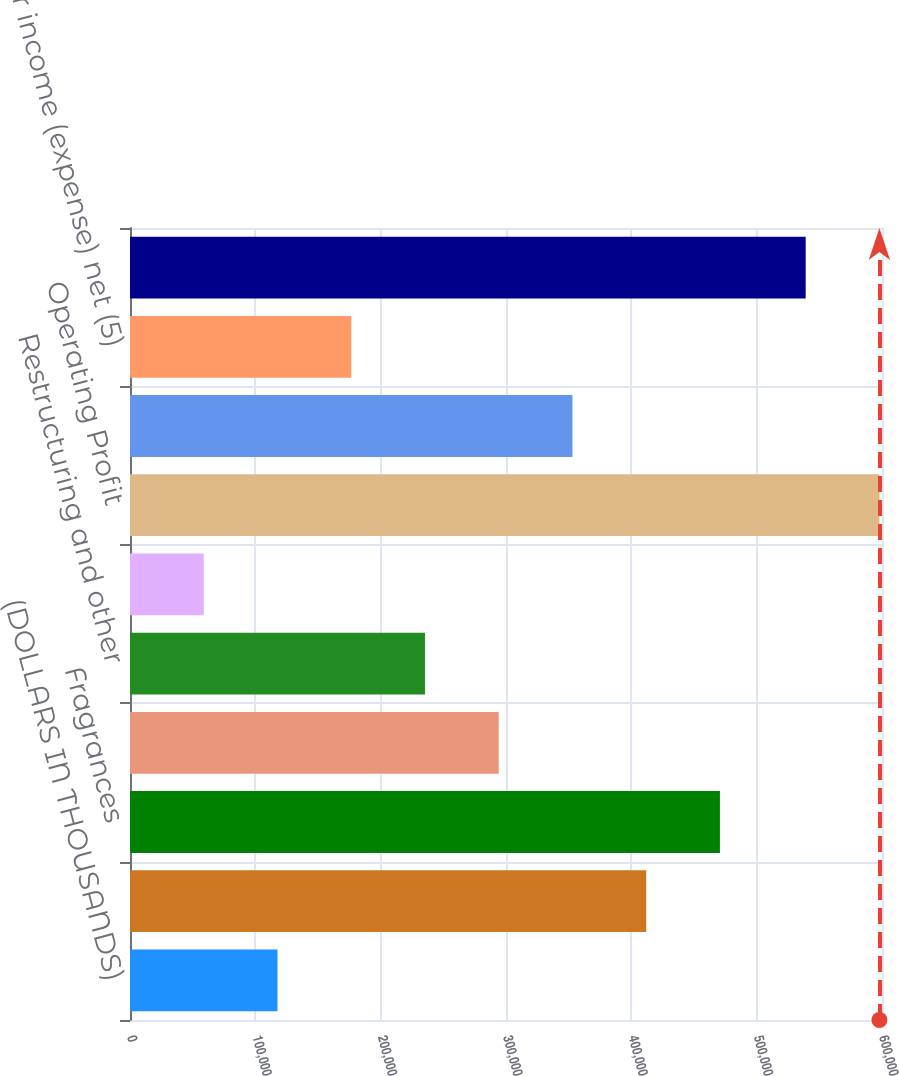Convert chart to OTSL. <chart><loc_0><loc_0><loc_500><loc_500><bar_chart><fcel>(DOLLARS IN THOUSANDS)<fcel>Flavors<fcel>Fragrances<fcel>Global expenses<fcel>Restructuring and other<fcel>Operational improvement<fcel>Operating Profit<fcel>Interest expense<fcel>Other income (expense) net (5)<fcel>Income before taxes<nl><fcel>117685<fcel>411849<fcel>470682<fcel>294183<fcel>235350<fcel>58852.2<fcel>597934<fcel>353016<fcel>176518<fcel>539101<nl></chart> 